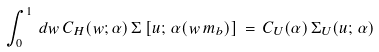<formula> <loc_0><loc_0><loc_500><loc_500>\int _ { 0 } ^ { 1 } \, d w \, C _ { H } ( w ; \alpha ) \, \Sigma \left [ u ; \, \alpha ( w \, m _ { b } ) \right ] \, = \, C _ { U } ( \alpha ) \, \Sigma _ { U } ( u ; \, \alpha )</formula> 